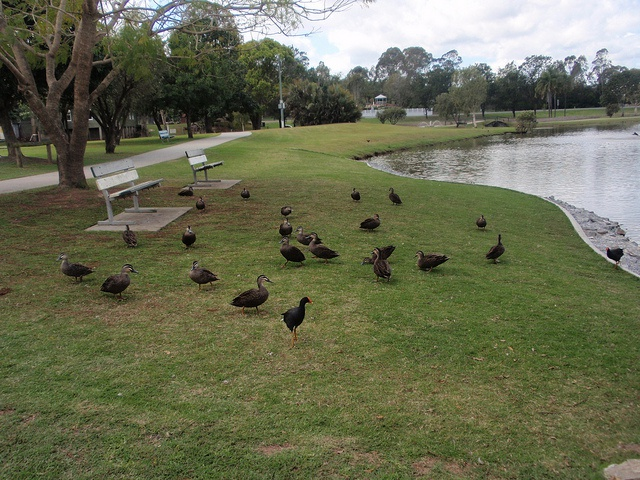Describe the objects in this image and their specific colors. I can see bird in gray, black, darkgreen, and olive tones, bench in gray, darkgray, and black tones, bench in gray, darkgray, darkgreen, and lightgray tones, bird in gray, black, olive, and maroon tones, and bird in gray and black tones in this image. 